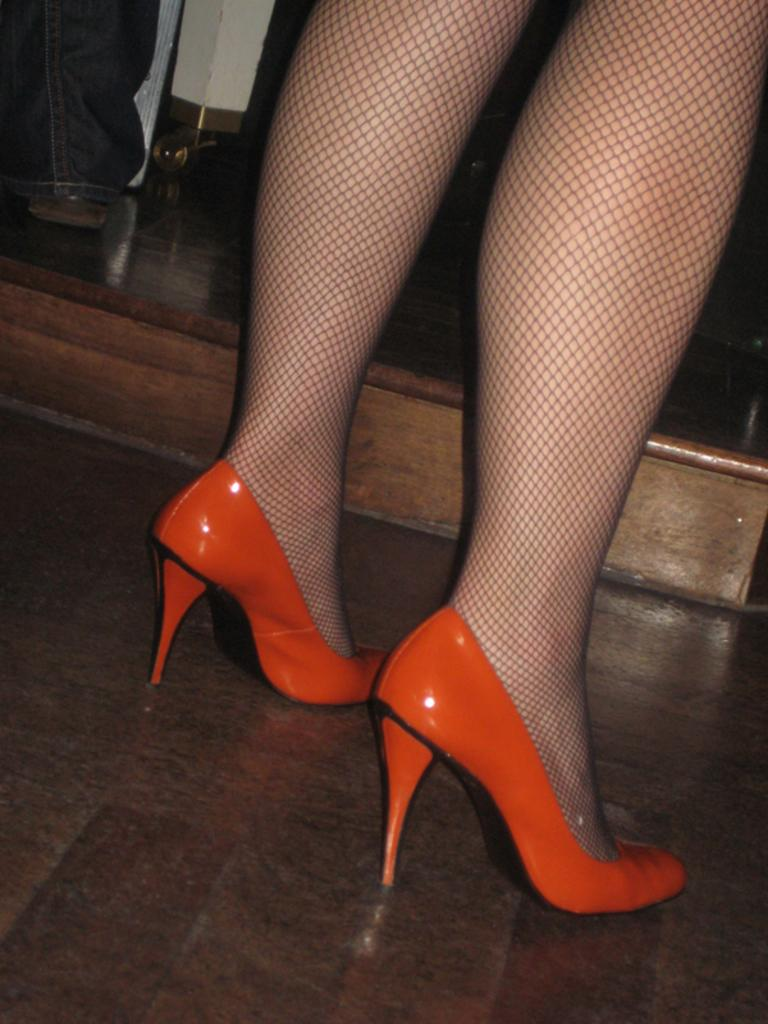Who or what is present in the image? There is a person in the image. What part of the person's body can be seen? The person's legs are visible in the image. What type of footwear is the person wearing? The person is wearing heels. What can be seen behind the person? There are objects in the background of the image. Are there any boys performing magic tricks for the person in the image? There is no mention of boys or magic tricks in the provided facts, so we cannot confirm their presence in the image. 